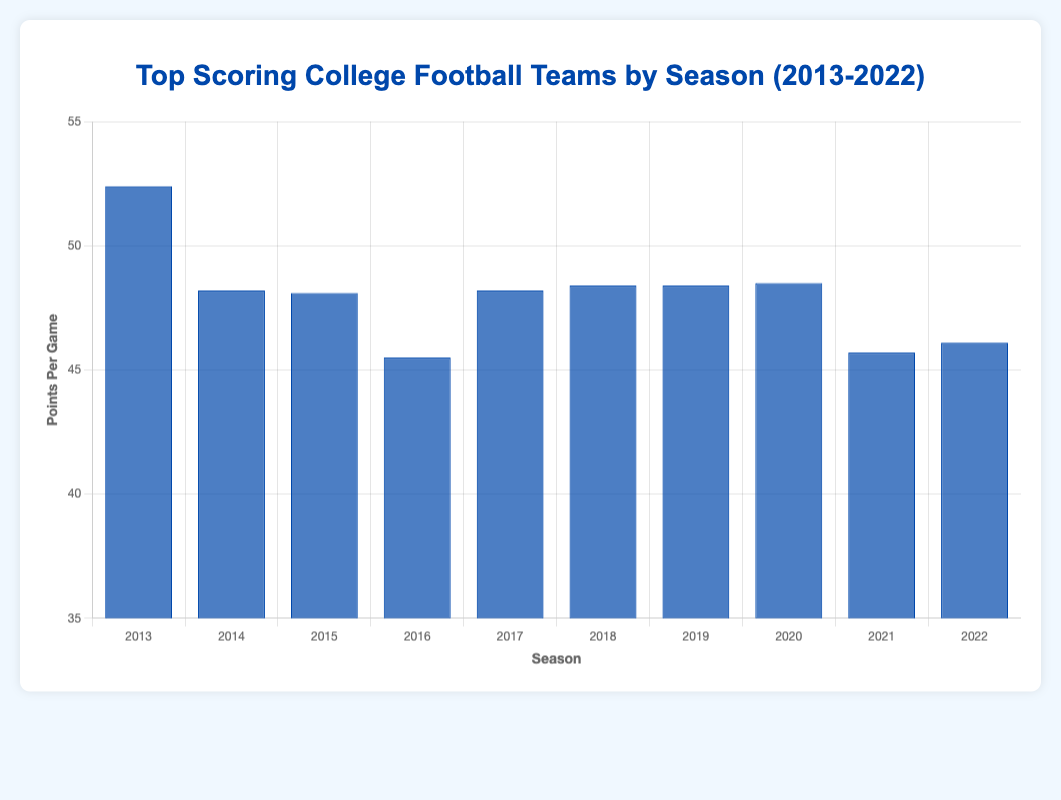Which team scored the most points per game in 2013? In 2013, the team with the highest points per game is Baylor with 52.4 points per game according to the blue bars.
Answer: Baylor How does the top team's scoring in 2017 compare to that in 2020? In 2017, UCF scored 48.2 points per game as the top team, while in 2020, Alabama scored 48.5 points per game as the top team.
Answer: Alabama scored 0.3 points more Which season shows the highest scoring top team, and how many points did they score? By examining the height of the blue bars, the season with the highest scoring top team is 2013, where Baylor scored 52.4 points per game.
Answer: 2013, 52.4 points per game What is the difference between the top-scoring team’s points per game in 2018 and 2019? The top-scoring team in 2018, Oklahoma, scored 48.4 points per game. In 2019, LSU scored 48.4 points per game. The difference is 0 points.
Answer: 0 points Which team appears as the top-scoring team in multiple seasons? Baylor appears as the top-scoring team in multiple seasons: 2013, 2014, and 2015.
Answer: Baylor What is the average points per game for the top teams from 2015 to 2017? In 2015, the top team Baylor scored 48.1 points per game. In 2016, Western Kentucky scored 45.5 points per game. In 2017, UCF scored 48.2 points per game. Average = (48.1 + 45.5 + 48.2) / 3 = 47.27
Answer: 47.27 points per game Is there any year where the top-scoring team scored less than 45 points per game? By observing the blue bars, in no year does the top-scoring team score less than 45 points per game.
Answer: No Which team had the highest points per game in 2022, and how does that compare to the top team in 2014? In 2022, Tennessee had the highest points per game with 46.1. In 2014, Baylor had the highest points per game with 48.2. Tennessee scored 2.1 points fewer.
Answer: Baylor in 2014 scored 2.1 points more What is the range of points per game for the top-scoring teams across the 10 years? The lowest points per game for a top-scoring team is 42.5 (Louisville, 2016) and the highest is 52.4 (Baylor, 2013). The range is 52.4 - 42.5 = 9.9 points per game.
Answer: 9.9 points per game Which team was the top scorer in 2020, and what was their points per game? In 2020, the top-scoring team was Alabama with 48.5 points per game according to the blue bars.
Answer: Alabama with 48.5 points per game 